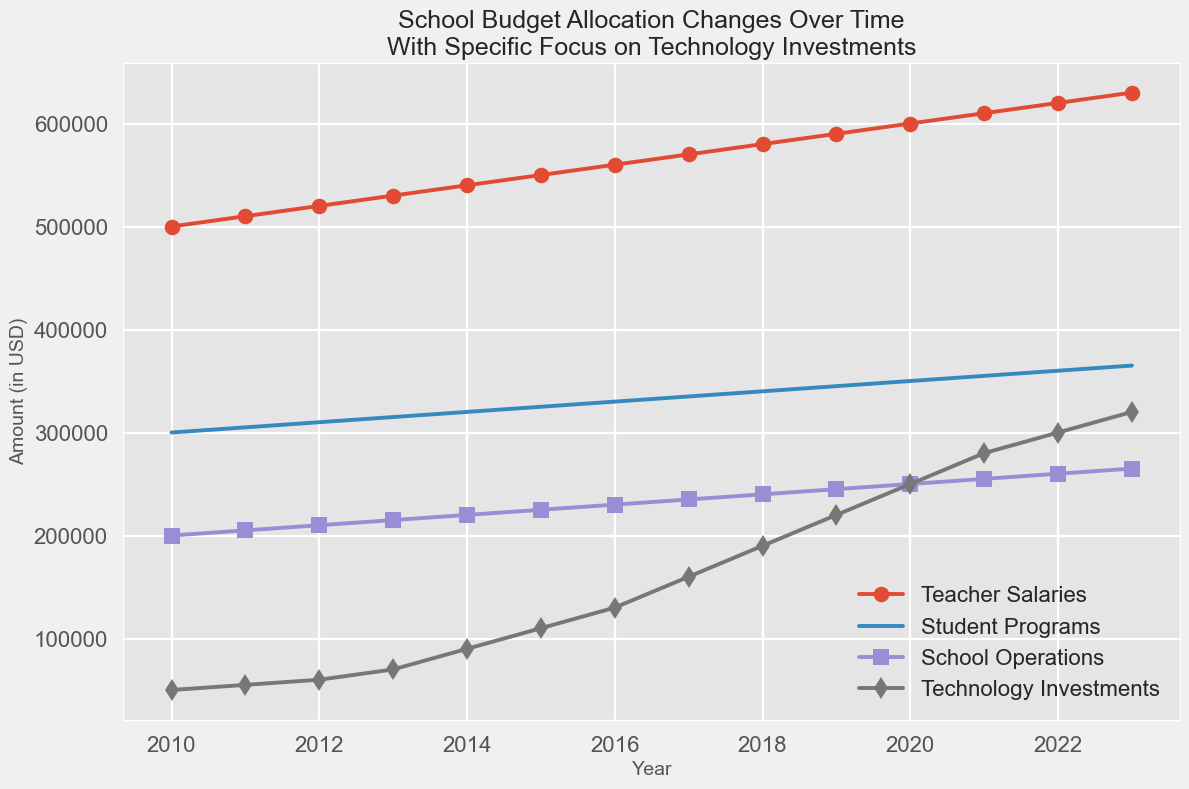What is the trend of Technology Investments from 2010 to 2023? The line for Technology Investments shows a consistent upward trend from 2010 to 2023, starting from $50,000 in 2010 and increasing each year to reach $320,000 in 2023.
Answer: Consistent upward trend Which budget item had the highest value in 2023? In the year 2023, the line representing Teacher Salaries reaches the highest point compared to the other lines, with a value of $630,000.
Answer: Teacher Salaries How much did Student Programs and Technology Investments combined increase from 2010 to 2023? Calculate the difference for both categories: Student Programs increased from $300,000 to $365,000 (a difference of $65,000) and Technology Investments increased from $50,000 to $320,000 (a difference of $270,000). The total combined increase is $65,000 + $270,000 = $335,000.
Answer: $335,000 Between 2015 and 2020, which budget category showed the largest absolute increase? Calculate the differences: Teacher Salaries increased by $50,000 ($600,000 - $550,000), Student Programs by $25,000 ($350,000 - $325,000), School Operations by $25,000 ($250,000 - $225,000), and Technology Investments by $140,000 ($250,000 - $110,000). Technology Investments showed the largest increase.
Answer: Technology Investments Which year did Technology Investments surpass School Operations in budget allocation? Look at the intersection points of the Technology Investments line and the School Operations line. Technology Investments surpasses the School Operations budget in 2017.
Answer: 2017 From 2020 to 2023, how does the rate of increase in Teacher Salaries compare to Technology Investments? Calculate the differences: Teacher Salaries increased by $30,000 ($630,000 - $600,000) and Technology Investments by $70,000 ($320,000 - $250,000). Technology Investments increased more than twice as much as Teacher Salaries.
Answer: Technology Investments increased faster Which category experienced the smallest increase from 2010 to 2023, and by how much? Calculate the differences for all categories: Teacher Salaries increased by $130,000 ($630,000 - $500,000), Student Programs by $65,000 ($365,000 - $300,000), School Operations by $65,000 ($265,000 - $200,000), and Technology Investments by $270,000 ($320,000 - $50,000). The smallest increase was in Student Programs and School Operations, both at $65,000.
Answer: Student Programs and School Operations, $65,000 How do the trends of Teacher Salaries and Student Programs compare over the given period? Both Teacher Salaries and Student Programs have consistent upward trends. However, Teacher Salaries show a slightly steeper increase compared to Student Programs each year.
Answer: Teacher Salaries increased more steeply By how much did the budget for School Operations change from 2011 to 2023? Calculate the difference for School Operations: $265,000 in 2023 minus $205,000 in 2011 equals an increase of $60,000.
Answer: $60,000 In which year was the budget for Technology Investments exactly double that of Student Programs? Identify the year where Technology Investments is approximately double of Student Programs. In 2023, Technology Investments are $320,000 and Student Programs are $365,000, which is close to double.
Answer: 2023 (approximate) 